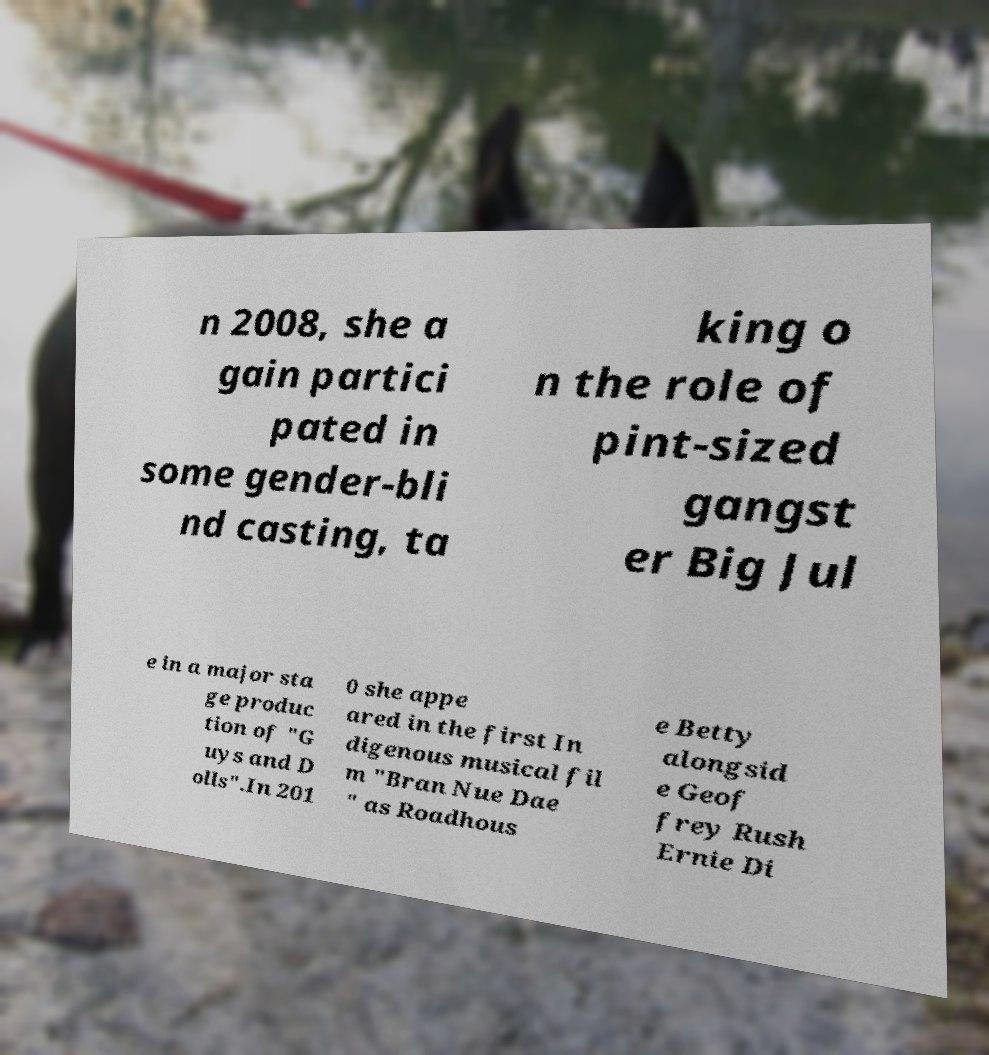Can you accurately transcribe the text from the provided image for me? n 2008, she a gain partici pated in some gender-bli nd casting, ta king o n the role of pint-sized gangst er Big Jul e in a major sta ge produc tion of "G uys and D olls".In 201 0 she appe ared in the first In digenous musical fil m "Bran Nue Dae " as Roadhous e Betty alongsid e Geof frey Rush Ernie Di 